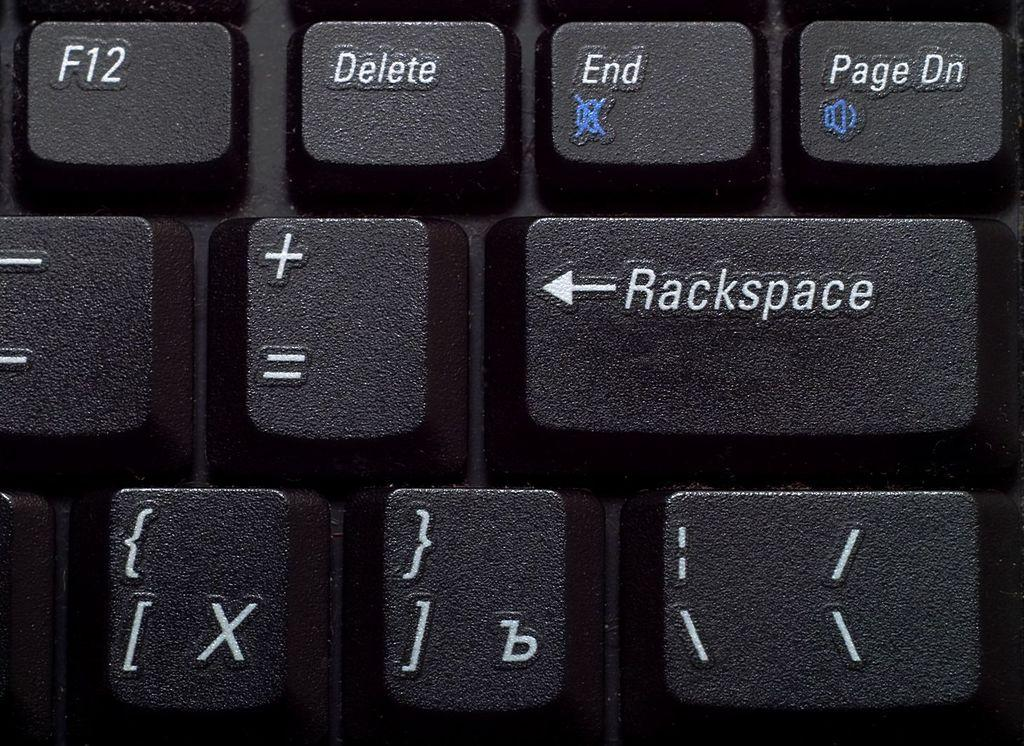<image>
Summarize the visual content of the image. keys on a keyboard with a middle key that says 'rackspace' 